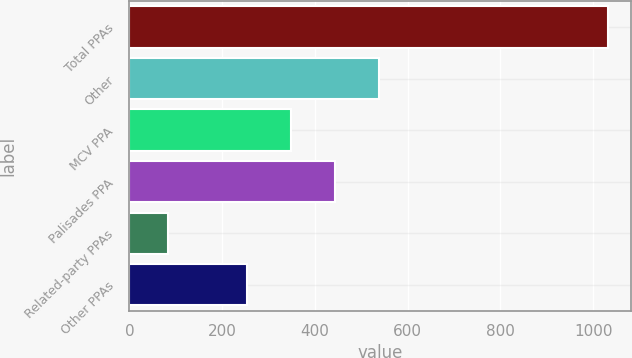Convert chart. <chart><loc_0><loc_0><loc_500><loc_500><bar_chart><fcel>Total PPAs<fcel>Other<fcel>MCV PPA<fcel>Palisades PPA<fcel>Related-party PPAs<fcel>Other PPAs<nl><fcel>1031<fcel>537.7<fcel>347.9<fcel>442.8<fcel>82<fcel>253<nl></chart> 